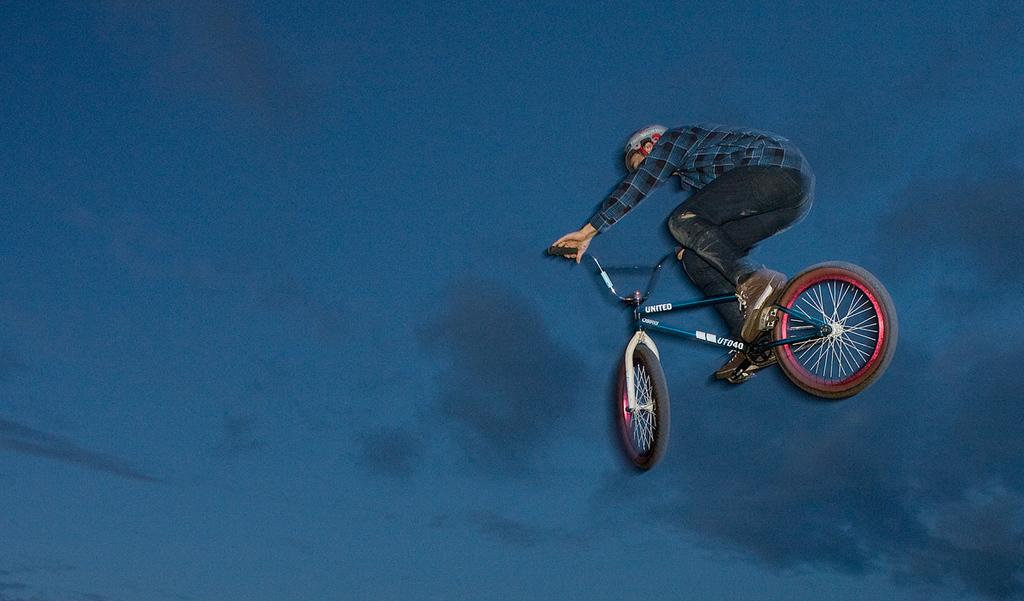What is the main subject of the image? There is a person in the image. What is the person doing in the image? The person is riding a bicycle. What safety gear is the person wearing? The person is wearing a helmet. What can be seen in the background of the image? There is sky visible in the background of the image. Can you tell me how many pickles are on the bicycle in the image? There are no pickles present in the image; the person is riding a bicycle and wearing a helmet. What type of cow can be seen grazing in the background of the image? There is no cow present in the image; the background only shows the sky. 